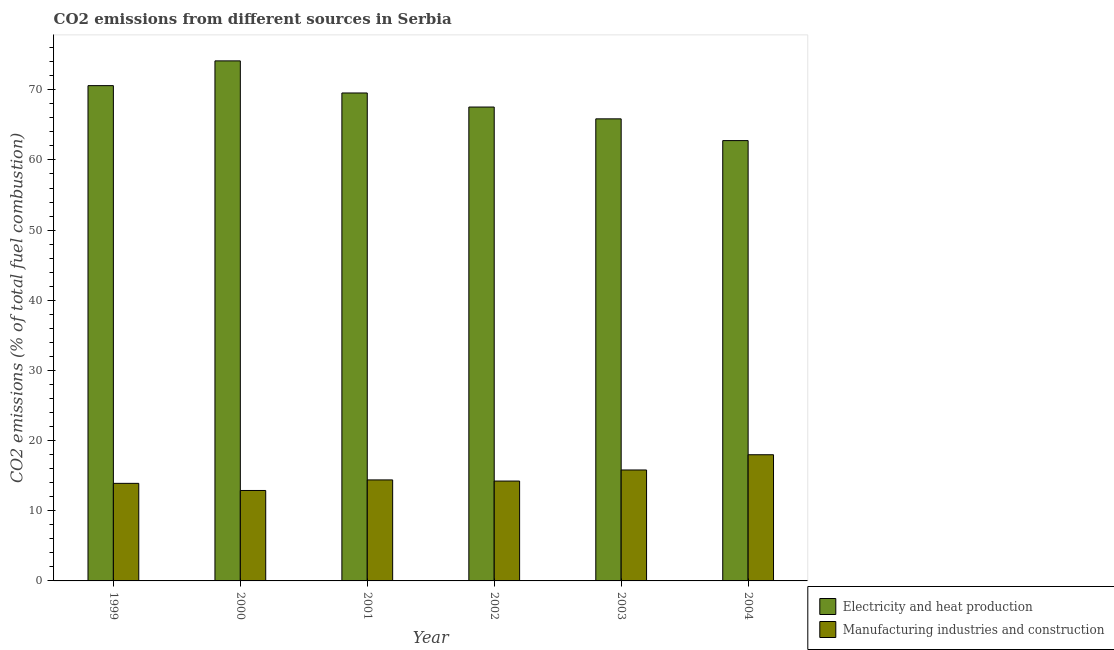How many different coloured bars are there?
Ensure brevity in your answer.  2. Are the number of bars per tick equal to the number of legend labels?
Your response must be concise. Yes. Are the number of bars on each tick of the X-axis equal?
Make the answer very short. Yes. In how many cases, is the number of bars for a given year not equal to the number of legend labels?
Keep it short and to the point. 0. What is the co2 emissions due to electricity and heat production in 1999?
Provide a succinct answer. 70.6. Across all years, what is the maximum co2 emissions due to manufacturing industries?
Provide a short and direct response. 17.99. Across all years, what is the minimum co2 emissions due to electricity and heat production?
Give a very brief answer. 62.76. In which year was the co2 emissions due to electricity and heat production minimum?
Make the answer very short. 2004. What is the total co2 emissions due to electricity and heat production in the graph?
Offer a terse response. 410.43. What is the difference between the co2 emissions due to electricity and heat production in 2001 and that in 2002?
Your answer should be compact. 2. What is the difference between the co2 emissions due to manufacturing industries in 2001 and the co2 emissions due to electricity and heat production in 2004?
Your answer should be very brief. -3.59. What is the average co2 emissions due to electricity and heat production per year?
Keep it short and to the point. 68.41. In the year 2002, what is the difference between the co2 emissions due to electricity and heat production and co2 emissions due to manufacturing industries?
Your response must be concise. 0. In how many years, is the co2 emissions due to electricity and heat production greater than 30 %?
Make the answer very short. 6. What is the ratio of the co2 emissions due to electricity and heat production in 1999 to that in 2000?
Keep it short and to the point. 0.95. Is the difference between the co2 emissions due to manufacturing industries in 1999 and 2001 greater than the difference between the co2 emissions due to electricity and heat production in 1999 and 2001?
Your answer should be compact. No. What is the difference between the highest and the second highest co2 emissions due to manufacturing industries?
Offer a terse response. 2.17. What is the difference between the highest and the lowest co2 emissions due to manufacturing industries?
Your response must be concise. 5.09. In how many years, is the co2 emissions due to manufacturing industries greater than the average co2 emissions due to manufacturing industries taken over all years?
Make the answer very short. 2. Is the sum of the co2 emissions due to electricity and heat production in 1999 and 2002 greater than the maximum co2 emissions due to manufacturing industries across all years?
Your response must be concise. Yes. What does the 2nd bar from the left in 2001 represents?
Provide a succinct answer. Manufacturing industries and construction. What does the 1st bar from the right in 2004 represents?
Your response must be concise. Manufacturing industries and construction. Are all the bars in the graph horizontal?
Offer a very short reply. No. How many years are there in the graph?
Offer a terse response. 6. What is the difference between two consecutive major ticks on the Y-axis?
Your answer should be compact. 10. Are the values on the major ticks of Y-axis written in scientific E-notation?
Offer a very short reply. No. Does the graph contain any zero values?
Offer a terse response. No. What is the title of the graph?
Keep it short and to the point. CO2 emissions from different sources in Serbia. Does "Agricultural land" appear as one of the legend labels in the graph?
Your response must be concise. No. What is the label or title of the X-axis?
Offer a very short reply. Year. What is the label or title of the Y-axis?
Give a very brief answer. CO2 emissions (% of total fuel combustion). What is the CO2 emissions (% of total fuel combustion) of Electricity and heat production in 1999?
Your response must be concise. 70.6. What is the CO2 emissions (% of total fuel combustion) in Manufacturing industries and construction in 1999?
Provide a short and direct response. 13.91. What is the CO2 emissions (% of total fuel combustion) in Electricity and heat production in 2000?
Provide a succinct answer. 74.12. What is the CO2 emissions (% of total fuel combustion) of Manufacturing industries and construction in 2000?
Ensure brevity in your answer.  12.89. What is the CO2 emissions (% of total fuel combustion) in Electricity and heat production in 2001?
Your response must be concise. 69.55. What is the CO2 emissions (% of total fuel combustion) of Manufacturing industries and construction in 2001?
Ensure brevity in your answer.  14.4. What is the CO2 emissions (% of total fuel combustion) in Electricity and heat production in 2002?
Provide a succinct answer. 67.55. What is the CO2 emissions (% of total fuel combustion) of Manufacturing industries and construction in 2002?
Offer a terse response. 14.24. What is the CO2 emissions (% of total fuel combustion) of Electricity and heat production in 2003?
Provide a succinct answer. 65.86. What is the CO2 emissions (% of total fuel combustion) in Manufacturing industries and construction in 2003?
Keep it short and to the point. 15.81. What is the CO2 emissions (% of total fuel combustion) of Electricity and heat production in 2004?
Make the answer very short. 62.76. What is the CO2 emissions (% of total fuel combustion) of Manufacturing industries and construction in 2004?
Make the answer very short. 17.99. Across all years, what is the maximum CO2 emissions (% of total fuel combustion) in Electricity and heat production?
Give a very brief answer. 74.12. Across all years, what is the maximum CO2 emissions (% of total fuel combustion) of Manufacturing industries and construction?
Ensure brevity in your answer.  17.99. Across all years, what is the minimum CO2 emissions (% of total fuel combustion) of Electricity and heat production?
Offer a terse response. 62.76. Across all years, what is the minimum CO2 emissions (% of total fuel combustion) of Manufacturing industries and construction?
Your response must be concise. 12.89. What is the total CO2 emissions (% of total fuel combustion) of Electricity and heat production in the graph?
Give a very brief answer. 410.43. What is the total CO2 emissions (% of total fuel combustion) of Manufacturing industries and construction in the graph?
Give a very brief answer. 89.23. What is the difference between the CO2 emissions (% of total fuel combustion) in Electricity and heat production in 1999 and that in 2000?
Keep it short and to the point. -3.53. What is the difference between the CO2 emissions (% of total fuel combustion) of Manufacturing industries and construction in 1999 and that in 2000?
Provide a short and direct response. 1.02. What is the difference between the CO2 emissions (% of total fuel combustion) of Electricity and heat production in 1999 and that in 2001?
Your response must be concise. 1.05. What is the difference between the CO2 emissions (% of total fuel combustion) in Manufacturing industries and construction in 1999 and that in 2001?
Give a very brief answer. -0.49. What is the difference between the CO2 emissions (% of total fuel combustion) in Electricity and heat production in 1999 and that in 2002?
Provide a succinct answer. 3.05. What is the difference between the CO2 emissions (% of total fuel combustion) in Manufacturing industries and construction in 1999 and that in 2002?
Offer a terse response. -0.33. What is the difference between the CO2 emissions (% of total fuel combustion) in Electricity and heat production in 1999 and that in 2003?
Offer a very short reply. 4.73. What is the difference between the CO2 emissions (% of total fuel combustion) of Manufacturing industries and construction in 1999 and that in 2003?
Offer a very short reply. -1.91. What is the difference between the CO2 emissions (% of total fuel combustion) of Electricity and heat production in 1999 and that in 2004?
Keep it short and to the point. 7.83. What is the difference between the CO2 emissions (% of total fuel combustion) in Manufacturing industries and construction in 1999 and that in 2004?
Provide a succinct answer. -4.08. What is the difference between the CO2 emissions (% of total fuel combustion) in Electricity and heat production in 2000 and that in 2001?
Your answer should be compact. 4.58. What is the difference between the CO2 emissions (% of total fuel combustion) in Manufacturing industries and construction in 2000 and that in 2001?
Offer a very short reply. -1.51. What is the difference between the CO2 emissions (% of total fuel combustion) in Electricity and heat production in 2000 and that in 2002?
Your response must be concise. 6.58. What is the difference between the CO2 emissions (% of total fuel combustion) in Manufacturing industries and construction in 2000 and that in 2002?
Your answer should be compact. -1.34. What is the difference between the CO2 emissions (% of total fuel combustion) in Electricity and heat production in 2000 and that in 2003?
Give a very brief answer. 8.26. What is the difference between the CO2 emissions (% of total fuel combustion) in Manufacturing industries and construction in 2000 and that in 2003?
Offer a terse response. -2.92. What is the difference between the CO2 emissions (% of total fuel combustion) of Electricity and heat production in 2000 and that in 2004?
Make the answer very short. 11.36. What is the difference between the CO2 emissions (% of total fuel combustion) of Manufacturing industries and construction in 2000 and that in 2004?
Provide a short and direct response. -5.09. What is the difference between the CO2 emissions (% of total fuel combustion) of Electricity and heat production in 2001 and that in 2002?
Ensure brevity in your answer.  2. What is the difference between the CO2 emissions (% of total fuel combustion) of Manufacturing industries and construction in 2001 and that in 2002?
Provide a succinct answer. 0.16. What is the difference between the CO2 emissions (% of total fuel combustion) of Electricity and heat production in 2001 and that in 2003?
Ensure brevity in your answer.  3.69. What is the difference between the CO2 emissions (% of total fuel combustion) of Manufacturing industries and construction in 2001 and that in 2003?
Your answer should be very brief. -1.42. What is the difference between the CO2 emissions (% of total fuel combustion) in Electricity and heat production in 2001 and that in 2004?
Offer a terse response. 6.79. What is the difference between the CO2 emissions (% of total fuel combustion) in Manufacturing industries and construction in 2001 and that in 2004?
Your answer should be compact. -3.59. What is the difference between the CO2 emissions (% of total fuel combustion) of Electricity and heat production in 2002 and that in 2003?
Make the answer very short. 1.68. What is the difference between the CO2 emissions (% of total fuel combustion) of Manufacturing industries and construction in 2002 and that in 2003?
Make the answer very short. -1.58. What is the difference between the CO2 emissions (% of total fuel combustion) of Electricity and heat production in 2002 and that in 2004?
Your response must be concise. 4.78. What is the difference between the CO2 emissions (% of total fuel combustion) in Manufacturing industries and construction in 2002 and that in 2004?
Keep it short and to the point. -3.75. What is the difference between the CO2 emissions (% of total fuel combustion) of Electricity and heat production in 2003 and that in 2004?
Make the answer very short. 3.1. What is the difference between the CO2 emissions (% of total fuel combustion) of Manufacturing industries and construction in 2003 and that in 2004?
Your answer should be compact. -2.17. What is the difference between the CO2 emissions (% of total fuel combustion) in Electricity and heat production in 1999 and the CO2 emissions (% of total fuel combustion) in Manufacturing industries and construction in 2000?
Provide a short and direct response. 57.7. What is the difference between the CO2 emissions (% of total fuel combustion) in Electricity and heat production in 1999 and the CO2 emissions (% of total fuel combustion) in Manufacturing industries and construction in 2001?
Keep it short and to the point. 56.2. What is the difference between the CO2 emissions (% of total fuel combustion) of Electricity and heat production in 1999 and the CO2 emissions (% of total fuel combustion) of Manufacturing industries and construction in 2002?
Provide a short and direct response. 56.36. What is the difference between the CO2 emissions (% of total fuel combustion) of Electricity and heat production in 1999 and the CO2 emissions (% of total fuel combustion) of Manufacturing industries and construction in 2003?
Offer a very short reply. 54.78. What is the difference between the CO2 emissions (% of total fuel combustion) of Electricity and heat production in 1999 and the CO2 emissions (% of total fuel combustion) of Manufacturing industries and construction in 2004?
Provide a succinct answer. 52.61. What is the difference between the CO2 emissions (% of total fuel combustion) in Electricity and heat production in 2000 and the CO2 emissions (% of total fuel combustion) in Manufacturing industries and construction in 2001?
Provide a succinct answer. 59.73. What is the difference between the CO2 emissions (% of total fuel combustion) of Electricity and heat production in 2000 and the CO2 emissions (% of total fuel combustion) of Manufacturing industries and construction in 2002?
Make the answer very short. 59.89. What is the difference between the CO2 emissions (% of total fuel combustion) in Electricity and heat production in 2000 and the CO2 emissions (% of total fuel combustion) in Manufacturing industries and construction in 2003?
Your answer should be compact. 58.31. What is the difference between the CO2 emissions (% of total fuel combustion) in Electricity and heat production in 2000 and the CO2 emissions (% of total fuel combustion) in Manufacturing industries and construction in 2004?
Provide a short and direct response. 56.14. What is the difference between the CO2 emissions (% of total fuel combustion) of Electricity and heat production in 2001 and the CO2 emissions (% of total fuel combustion) of Manufacturing industries and construction in 2002?
Offer a very short reply. 55.31. What is the difference between the CO2 emissions (% of total fuel combustion) of Electricity and heat production in 2001 and the CO2 emissions (% of total fuel combustion) of Manufacturing industries and construction in 2003?
Ensure brevity in your answer.  53.73. What is the difference between the CO2 emissions (% of total fuel combustion) of Electricity and heat production in 2001 and the CO2 emissions (% of total fuel combustion) of Manufacturing industries and construction in 2004?
Offer a very short reply. 51.56. What is the difference between the CO2 emissions (% of total fuel combustion) in Electricity and heat production in 2002 and the CO2 emissions (% of total fuel combustion) in Manufacturing industries and construction in 2003?
Make the answer very short. 51.73. What is the difference between the CO2 emissions (% of total fuel combustion) of Electricity and heat production in 2002 and the CO2 emissions (% of total fuel combustion) of Manufacturing industries and construction in 2004?
Provide a short and direct response. 49.56. What is the difference between the CO2 emissions (% of total fuel combustion) in Electricity and heat production in 2003 and the CO2 emissions (% of total fuel combustion) in Manufacturing industries and construction in 2004?
Offer a terse response. 47.88. What is the average CO2 emissions (% of total fuel combustion) of Electricity and heat production per year?
Keep it short and to the point. 68.41. What is the average CO2 emissions (% of total fuel combustion) in Manufacturing industries and construction per year?
Give a very brief answer. 14.87. In the year 1999, what is the difference between the CO2 emissions (% of total fuel combustion) in Electricity and heat production and CO2 emissions (% of total fuel combustion) in Manufacturing industries and construction?
Make the answer very short. 56.69. In the year 2000, what is the difference between the CO2 emissions (% of total fuel combustion) of Electricity and heat production and CO2 emissions (% of total fuel combustion) of Manufacturing industries and construction?
Provide a short and direct response. 61.23. In the year 2001, what is the difference between the CO2 emissions (% of total fuel combustion) in Electricity and heat production and CO2 emissions (% of total fuel combustion) in Manufacturing industries and construction?
Offer a terse response. 55.15. In the year 2002, what is the difference between the CO2 emissions (% of total fuel combustion) in Electricity and heat production and CO2 emissions (% of total fuel combustion) in Manufacturing industries and construction?
Your answer should be very brief. 53.31. In the year 2003, what is the difference between the CO2 emissions (% of total fuel combustion) in Electricity and heat production and CO2 emissions (% of total fuel combustion) in Manufacturing industries and construction?
Your answer should be compact. 50.05. In the year 2004, what is the difference between the CO2 emissions (% of total fuel combustion) in Electricity and heat production and CO2 emissions (% of total fuel combustion) in Manufacturing industries and construction?
Keep it short and to the point. 44.78. What is the ratio of the CO2 emissions (% of total fuel combustion) of Electricity and heat production in 1999 to that in 2000?
Keep it short and to the point. 0.95. What is the ratio of the CO2 emissions (% of total fuel combustion) in Manufacturing industries and construction in 1999 to that in 2000?
Keep it short and to the point. 1.08. What is the ratio of the CO2 emissions (% of total fuel combustion) of Electricity and heat production in 1999 to that in 2001?
Offer a very short reply. 1.02. What is the ratio of the CO2 emissions (% of total fuel combustion) in Manufacturing industries and construction in 1999 to that in 2001?
Make the answer very short. 0.97. What is the ratio of the CO2 emissions (% of total fuel combustion) in Electricity and heat production in 1999 to that in 2002?
Your response must be concise. 1.05. What is the ratio of the CO2 emissions (% of total fuel combustion) in Manufacturing industries and construction in 1999 to that in 2002?
Offer a very short reply. 0.98. What is the ratio of the CO2 emissions (% of total fuel combustion) of Electricity and heat production in 1999 to that in 2003?
Your answer should be compact. 1.07. What is the ratio of the CO2 emissions (% of total fuel combustion) of Manufacturing industries and construction in 1999 to that in 2003?
Your answer should be very brief. 0.88. What is the ratio of the CO2 emissions (% of total fuel combustion) in Electricity and heat production in 1999 to that in 2004?
Give a very brief answer. 1.12. What is the ratio of the CO2 emissions (% of total fuel combustion) in Manufacturing industries and construction in 1999 to that in 2004?
Provide a short and direct response. 0.77. What is the ratio of the CO2 emissions (% of total fuel combustion) of Electricity and heat production in 2000 to that in 2001?
Ensure brevity in your answer.  1.07. What is the ratio of the CO2 emissions (% of total fuel combustion) of Manufacturing industries and construction in 2000 to that in 2001?
Keep it short and to the point. 0.9. What is the ratio of the CO2 emissions (% of total fuel combustion) in Electricity and heat production in 2000 to that in 2002?
Your answer should be compact. 1.1. What is the ratio of the CO2 emissions (% of total fuel combustion) of Manufacturing industries and construction in 2000 to that in 2002?
Provide a succinct answer. 0.91. What is the ratio of the CO2 emissions (% of total fuel combustion) of Electricity and heat production in 2000 to that in 2003?
Your answer should be very brief. 1.13. What is the ratio of the CO2 emissions (% of total fuel combustion) of Manufacturing industries and construction in 2000 to that in 2003?
Your response must be concise. 0.82. What is the ratio of the CO2 emissions (% of total fuel combustion) of Electricity and heat production in 2000 to that in 2004?
Give a very brief answer. 1.18. What is the ratio of the CO2 emissions (% of total fuel combustion) of Manufacturing industries and construction in 2000 to that in 2004?
Your answer should be compact. 0.72. What is the ratio of the CO2 emissions (% of total fuel combustion) of Electricity and heat production in 2001 to that in 2002?
Offer a very short reply. 1.03. What is the ratio of the CO2 emissions (% of total fuel combustion) in Manufacturing industries and construction in 2001 to that in 2002?
Offer a very short reply. 1.01. What is the ratio of the CO2 emissions (% of total fuel combustion) in Electricity and heat production in 2001 to that in 2003?
Offer a very short reply. 1.06. What is the ratio of the CO2 emissions (% of total fuel combustion) in Manufacturing industries and construction in 2001 to that in 2003?
Offer a terse response. 0.91. What is the ratio of the CO2 emissions (% of total fuel combustion) in Electricity and heat production in 2001 to that in 2004?
Your answer should be very brief. 1.11. What is the ratio of the CO2 emissions (% of total fuel combustion) of Manufacturing industries and construction in 2001 to that in 2004?
Provide a succinct answer. 0.8. What is the ratio of the CO2 emissions (% of total fuel combustion) of Electricity and heat production in 2002 to that in 2003?
Your answer should be very brief. 1.03. What is the ratio of the CO2 emissions (% of total fuel combustion) in Manufacturing industries and construction in 2002 to that in 2003?
Ensure brevity in your answer.  0.9. What is the ratio of the CO2 emissions (% of total fuel combustion) of Electricity and heat production in 2002 to that in 2004?
Your answer should be very brief. 1.08. What is the ratio of the CO2 emissions (% of total fuel combustion) of Manufacturing industries and construction in 2002 to that in 2004?
Provide a short and direct response. 0.79. What is the ratio of the CO2 emissions (% of total fuel combustion) in Electricity and heat production in 2003 to that in 2004?
Offer a very short reply. 1.05. What is the ratio of the CO2 emissions (% of total fuel combustion) in Manufacturing industries and construction in 2003 to that in 2004?
Keep it short and to the point. 0.88. What is the difference between the highest and the second highest CO2 emissions (% of total fuel combustion) in Electricity and heat production?
Provide a succinct answer. 3.53. What is the difference between the highest and the second highest CO2 emissions (% of total fuel combustion) in Manufacturing industries and construction?
Ensure brevity in your answer.  2.17. What is the difference between the highest and the lowest CO2 emissions (% of total fuel combustion) in Electricity and heat production?
Make the answer very short. 11.36. What is the difference between the highest and the lowest CO2 emissions (% of total fuel combustion) in Manufacturing industries and construction?
Make the answer very short. 5.09. 